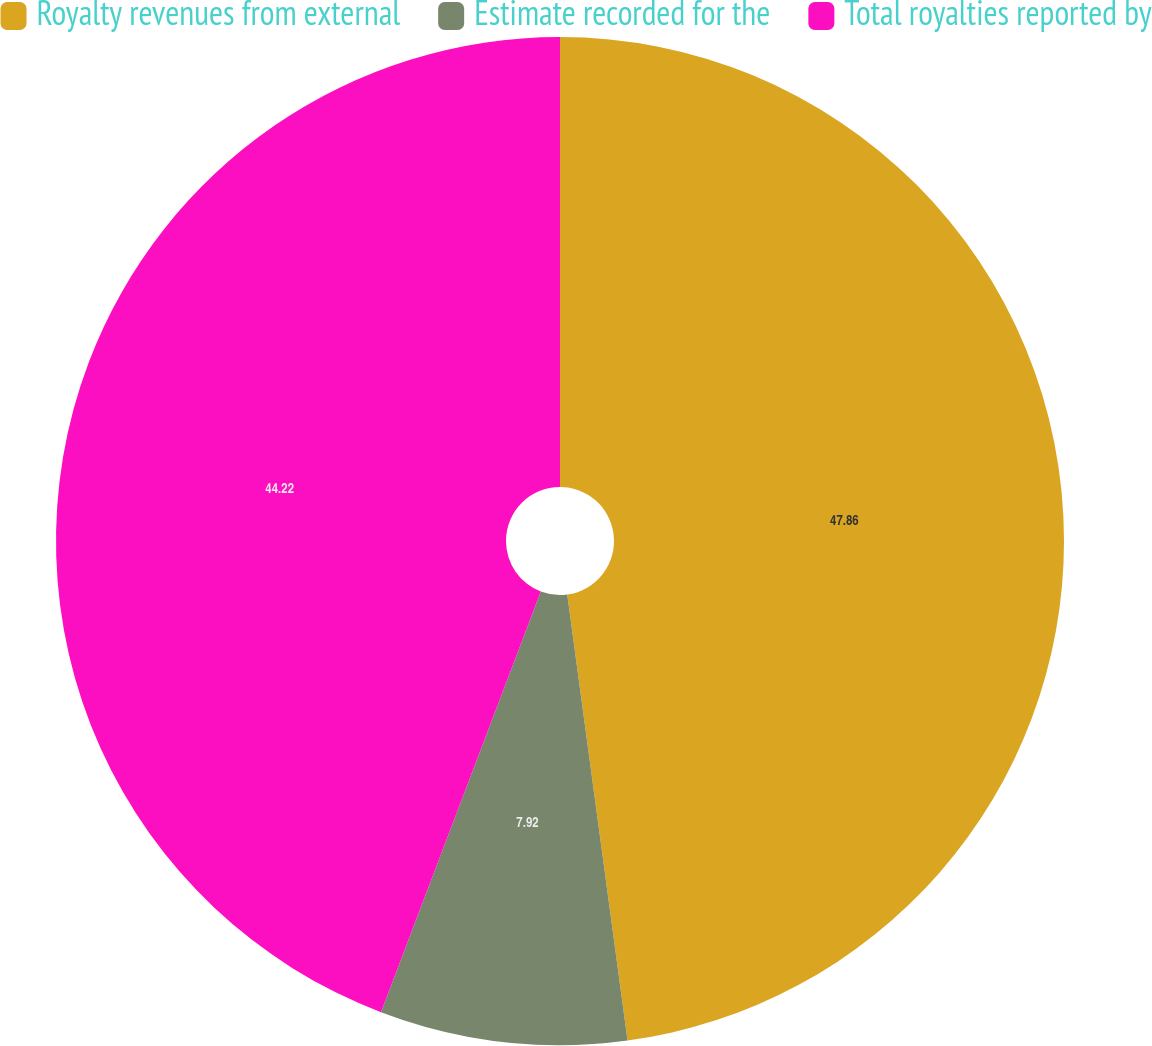<chart> <loc_0><loc_0><loc_500><loc_500><pie_chart><fcel>Royalty revenues from external<fcel>Estimate recorded for the<fcel>Total royalties reported by<nl><fcel>47.86%<fcel>7.92%<fcel>44.22%<nl></chart> 